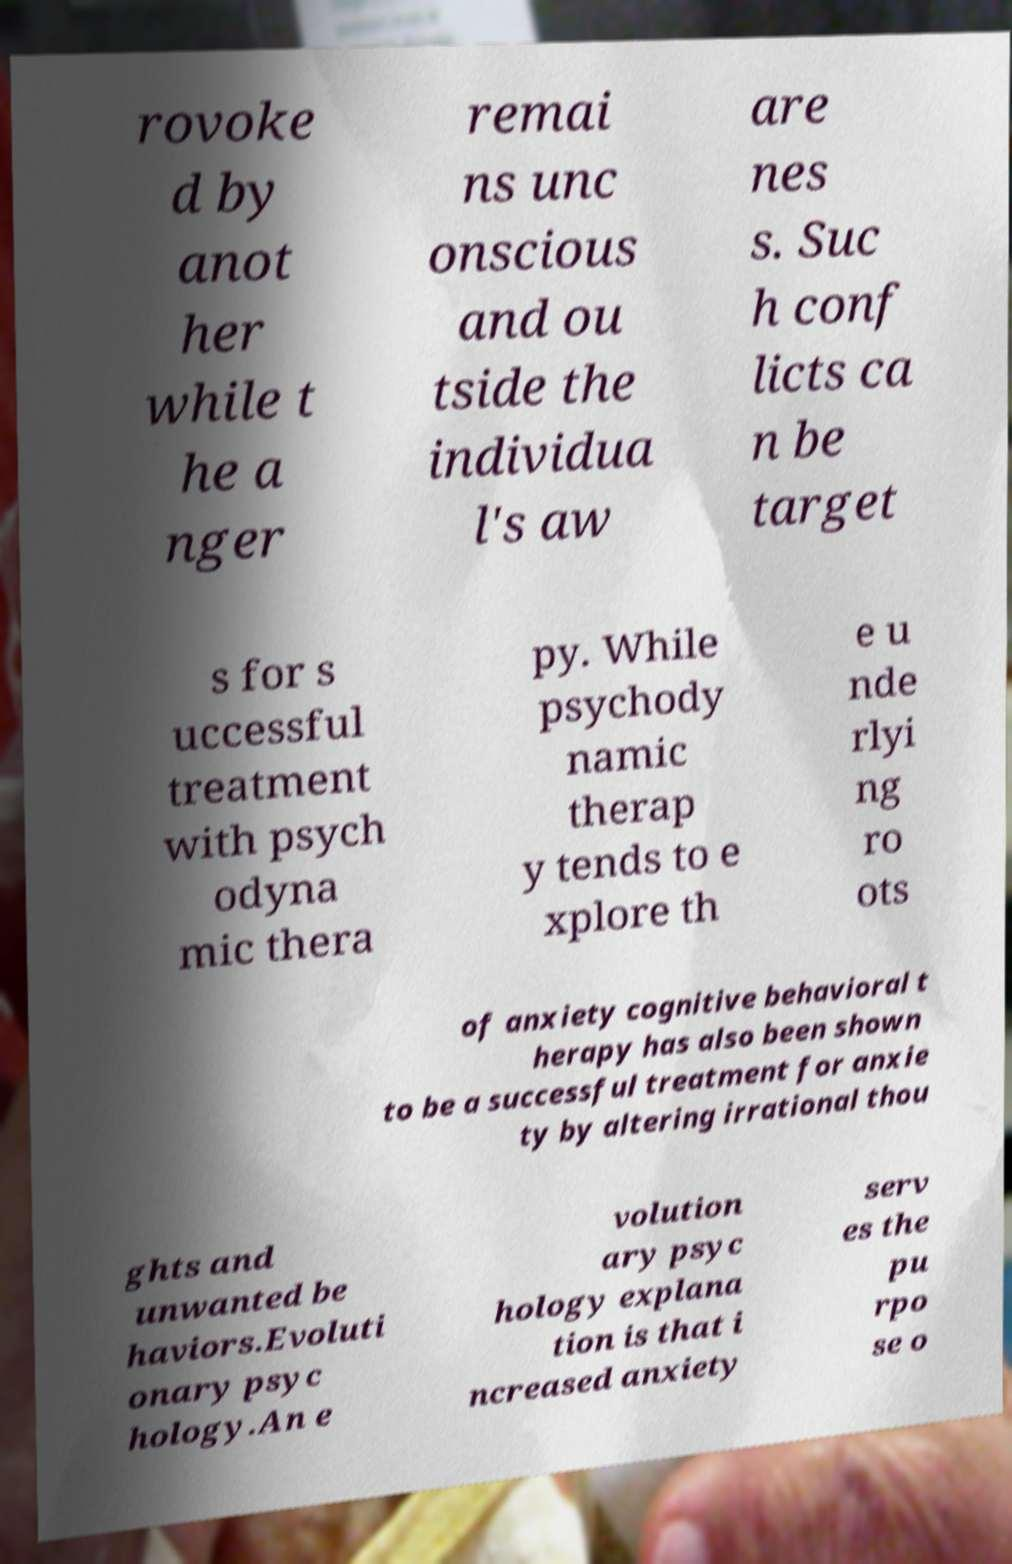I need the written content from this picture converted into text. Can you do that? rovoke d by anot her while t he a nger remai ns unc onscious and ou tside the individua l's aw are nes s. Suc h conf licts ca n be target s for s uccessful treatment with psych odyna mic thera py. While psychody namic therap y tends to e xplore th e u nde rlyi ng ro ots of anxiety cognitive behavioral t herapy has also been shown to be a successful treatment for anxie ty by altering irrational thou ghts and unwanted be haviors.Evoluti onary psyc hology.An e volution ary psyc hology explana tion is that i ncreased anxiety serv es the pu rpo se o 